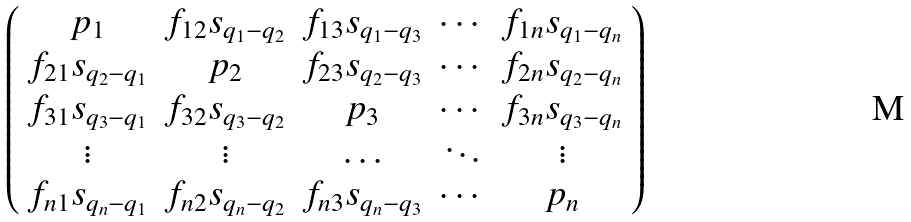Convert formula to latex. <formula><loc_0><loc_0><loc_500><loc_500>\left ( \begin{array} { c c c c c } p _ { 1 } & f _ { 1 2 } s _ { q _ { 1 } - q _ { 2 } } & f _ { 1 3 } s _ { q _ { 1 } - q _ { 3 } } & \cdots & f _ { 1 n } s _ { q _ { 1 } - q _ { n } } \\ f _ { 2 1 } s _ { q _ { 2 } - q _ { 1 } } & p _ { 2 } & f _ { 2 3 } s _ { q _ { 2 } - q _ { 3 } } & \cdots & f _ { 2 n } s _ { q _ { 2 } - q _ { n } } \\ f _ { 3 1 } s _ { q _ { 3 } - q _ { 1 } } & f _ { 3 2 } s _ { q _ { 3 } - q _ { 2 } } & p _ { 3 } & \cdots & f _ { 3 n } s _ { q _ { 3 } - q _ { n } } \\ \vdots & \vdots & \hdots & \ddots & \vdots \\ f _ { n 1 } s _ { q _ { n } - q _ { 1 } } & f _ { n 2 } s _ { q _ { n } - q _ { 2 } } & f _ { n 3 } s _ { q _ { n } - q _ { 3 } } & \cdots & p _ { n } \end{array} \right )</formula> 